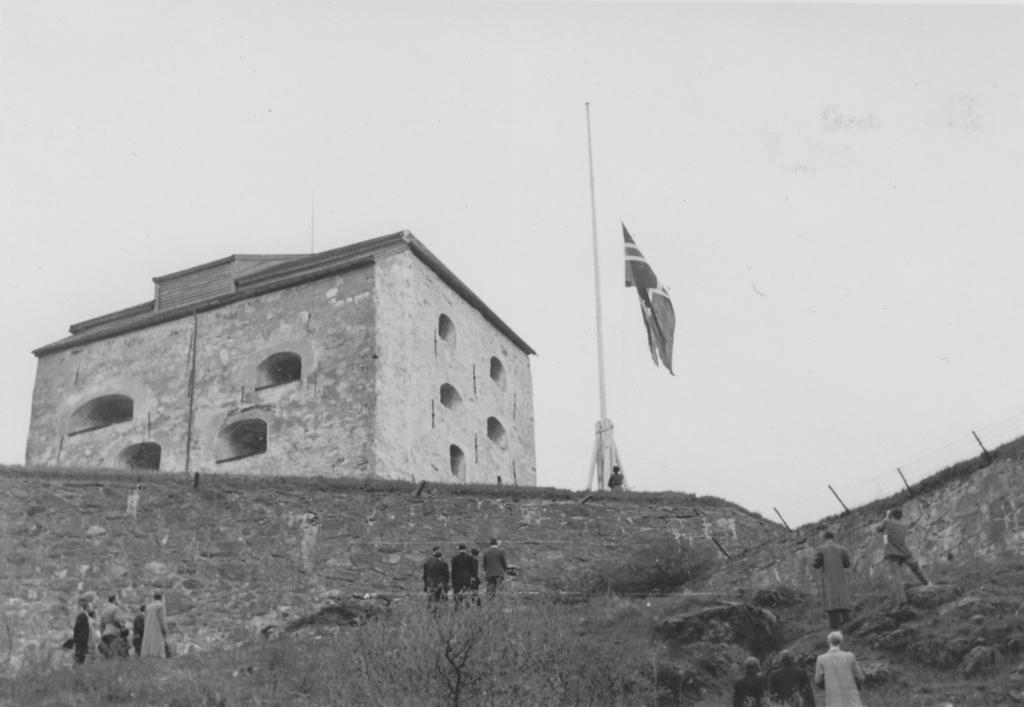What type of structure is present in the image? There is a building in the image. Are there any living beings visible in the image? Yes, there are people in the image. What other natural elements can be seen in the image? There are trees in the image. What is visible at the top of the image? The sky is visible at the top of the image. What symbol or emblem is located in the middle of the image? There is a flag in the middle of the image. What type of pancake is being sold at the market in the image? There is no market or pancake present in the image. What process is being carried out by the people in the image? The image does not provide enough information to determine the specific process or activity being carried out by the people. 